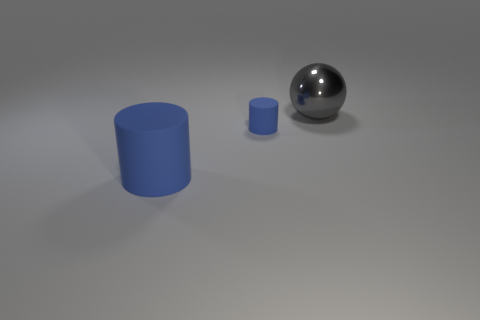What number of big gray shiny things are left of the cylinder in front of the tiny blue rubber thing?
Offer a terse response. 0. Does the tiny matte thing have the same color as the big matte object?
Keep it short and to the point. Yes. How many other objects are there of the same material as the small blue thing?
Make the answer very short. 1. There is a matte thing behind the large object in front of the gray sphere; what is its shape?
Offer a very short reply. Cylinder. There is a rubber object behind the large rubber object; how big is it?
Give a very brief answer. Small. Do the small thing and the large blue cylinder have the same material?
Your answer should be very brief. Yes. What is the shape of the tiny blue object that is the same material as the big blue object?
Make the answer very short. Cylinder. Is there any other thing of the same color as the large metal sphere?
Your response must be concise. No. There is a big thing that is in front of the large ball; what is its color?
Provide a succinct answer. Blue. There is a big object that is in front of the gray ball; is its color the same as the ball?
Provide a short and direct response. No. 